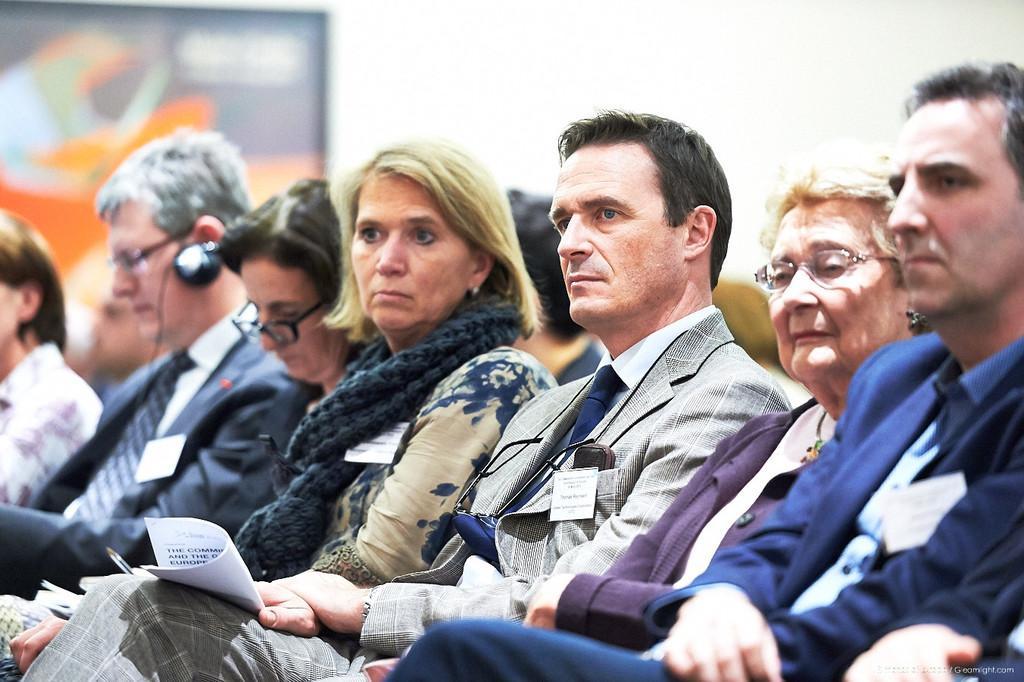In one or two sentences, can you explain what this image depicts? In this image I can see few people sitting and wearing different color dress. Few people are holding papers. Back I can see a white wall. 